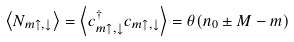<formula> <loc_0><loc_0><loc_500><loc_500>\left \langle N _ { m \uparrow , \downarrow } \right \rangle = \left \langle { c ^ { \dagger } _ { m \uparrow , \downarrow } } { c _ { m \uparrow , \downarrow } } \right \rangle = \theta ( { n _ { 0 } } \pm M - m )</formula> 